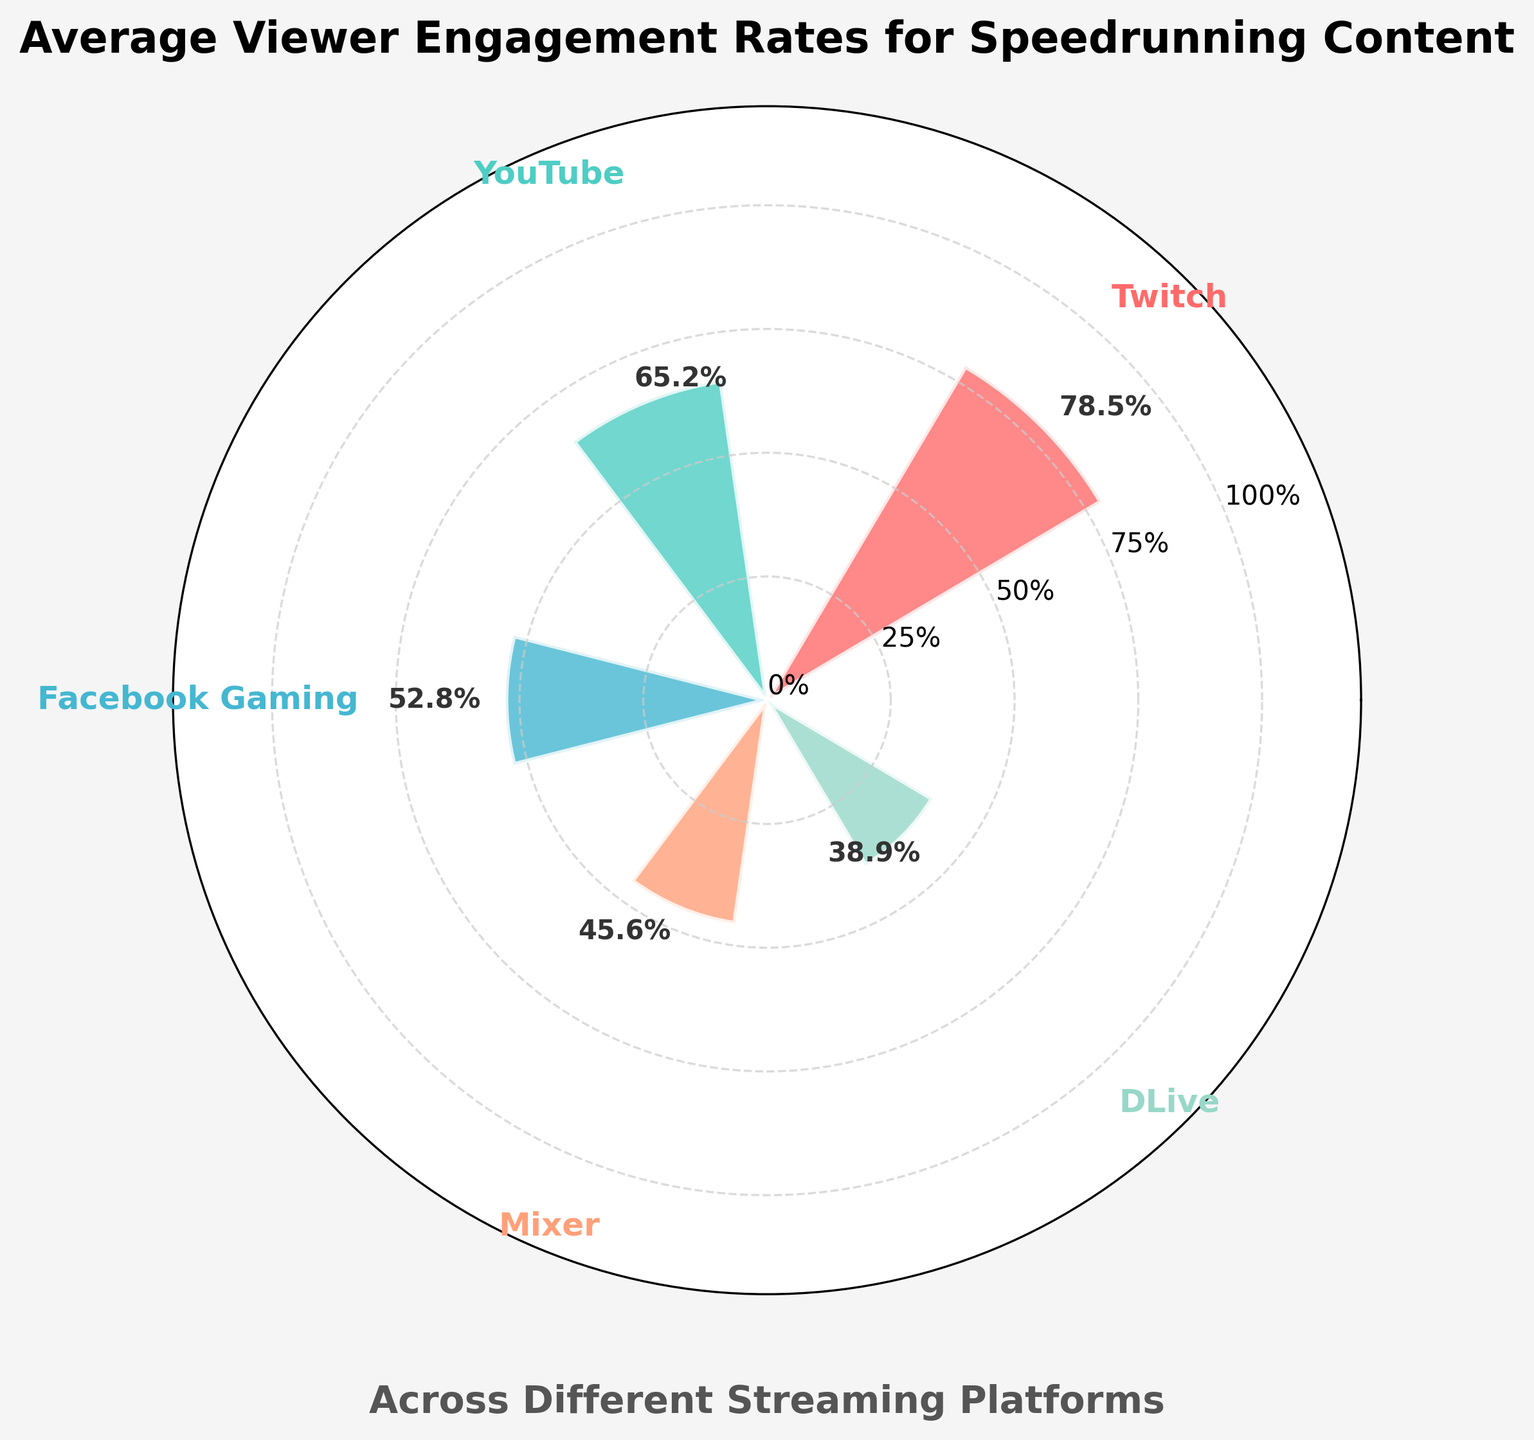What is the platform with the highest viewer engagement rate? The platform with the highest engagement rate is indicated by the bar that extends the furthest on the gauge chart. The bar for Twitch extends to 78.5%, which is the highest value displayed.
Answer: Twitch What is the title of the figure? The title is prominently displayed at the top of the figure. It reads, "Average Viewer Engagement Rates for Speedrunning Content."
Answer: Average Viewer Engagement Rates for Speedrunning Content How many platforms are compared in the gauge chart? Count the number of distinct bars representing different platforms. There are 5 bars, each for Twitch, YouTube, Facebook Gaming, Mixer, and DLive.
Answer: 5 What is the engagement rate for Facebook Gaming? Locate the bar for Facebook Gaming and refer to the value displayed next to it. The engagement rate is 52.8%.
Answer: 52.8% Which platform has the lowest viewer engagement rate? Identify the bar that extends the least on the gauge chart. The bar for DLive extends to 38.9%, the lowest value among all platforms.
Answer: DLive What is the total engagement rate of YouTube and Mixer combined? Add the engagement rates of YouTube and Mixer: 65.2% (YouTube) + 45.6% (Mixer) = 110.8%.
Answer: 110.8% Are there more platforms with an engagement rate above 50% or below 50%? Count the number of platforms with engagement rates above 50% (Twitch, YouTube, Facebook Gaming) and those below 50% (Mixer, DLive). There are 3 platforms above 50% and 2 platforms below 50%.
Answer: Above 50% What is the average engagement rate across all platforms? Calculate the sum of the engagement rates and divide by the number of platforms: (78.5 + 65.2 + 52.8 + 45.6 + 38.9) / 5 = 56.2%.
Answer: 56.2% Which platform shows almost double the engagement rate compared to Mixer? Identify the engagement rate for Mixer (45.6%) and look for a rate that is approximately double. Twitch has an engagement rate of 78.5%, which is close to double Mixer's rate.
Answer: Twitch 